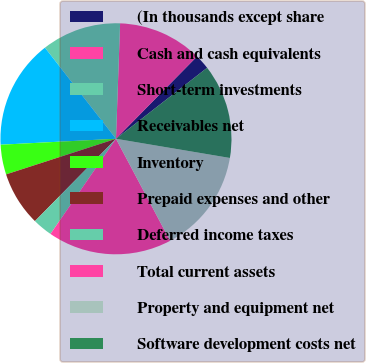<chart> <loc_0><loc_0><loc_500><loc_500><pie_chart><fcel>(In thousands except share<fcel>Cash and cash equivalents<fcel>Short-term investments<fcel>Receivables net<fcel>Inventory<fcel>Prepaid expenses and other<fcel>Deferred income taxes<fcel>Total current assets<fcel>Property and equipment net<fcel>Software development costs net<nl><fcel>2.09%<fcel>11.81%<fcel>11.11%<fcel>15.28%<fcel>4.17%<fcel>7.64%<fcel>2.78%<fcel>17.36%<fcel>14.58%<fcel>13.19%<nl></chart> 